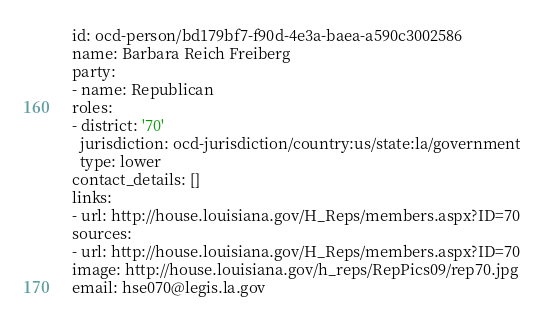<code> <loc_0><loc_0><loc_500><loc_500><_YAML_>id: ocd-person/bd179bf7-f90d-4e3a-baea-a590c3002586
name: Barbara Reich Freiberg
party:
- name: Republican
roles:
- district: '70'
  jurisdiction: ocd-jurisdiction/country:us/state:la/government
  type: lower
contact_details: []
links:
- url: http://house.louisiana.gov/H_Reps/members.aspx?ID=70
sources:
- url: http://house.louisiana.gov/H_Reps/members.aspx?ID=70
image: http://house.louisiana.gov/h_reps/RepPics09/rep70.jpg
email: hse070@legis.la.gov
</code> 